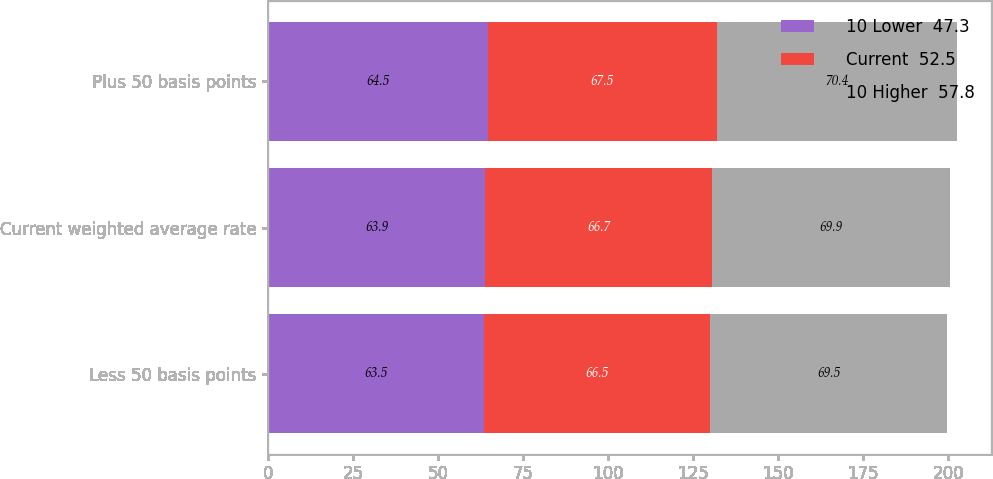<chart> <loc_0><loc_0><loc_500><loc_500><stacked_bar_chart><ecel><fcel>Less 50 basis points<fcel>Current weighted average rate<fcel>Plus 50 basis points<nl><fcel>10 Lower  47.3<fcel>63.5<fcel>63.9<fcel>64.5<nl><fcel>Current  52.5<fcel>66.5<fcel>66.7<fcel>67.5<nl><fcel>10 Higher  57.8<fcel>69.5<fcel>69.9<fcel>70.4<nl></chart> 